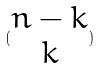<formula> <loc_0><loc_0><loc_500><loc_500>( \begin{matrix} n - k \\ k \end{matrix} )</formula> 